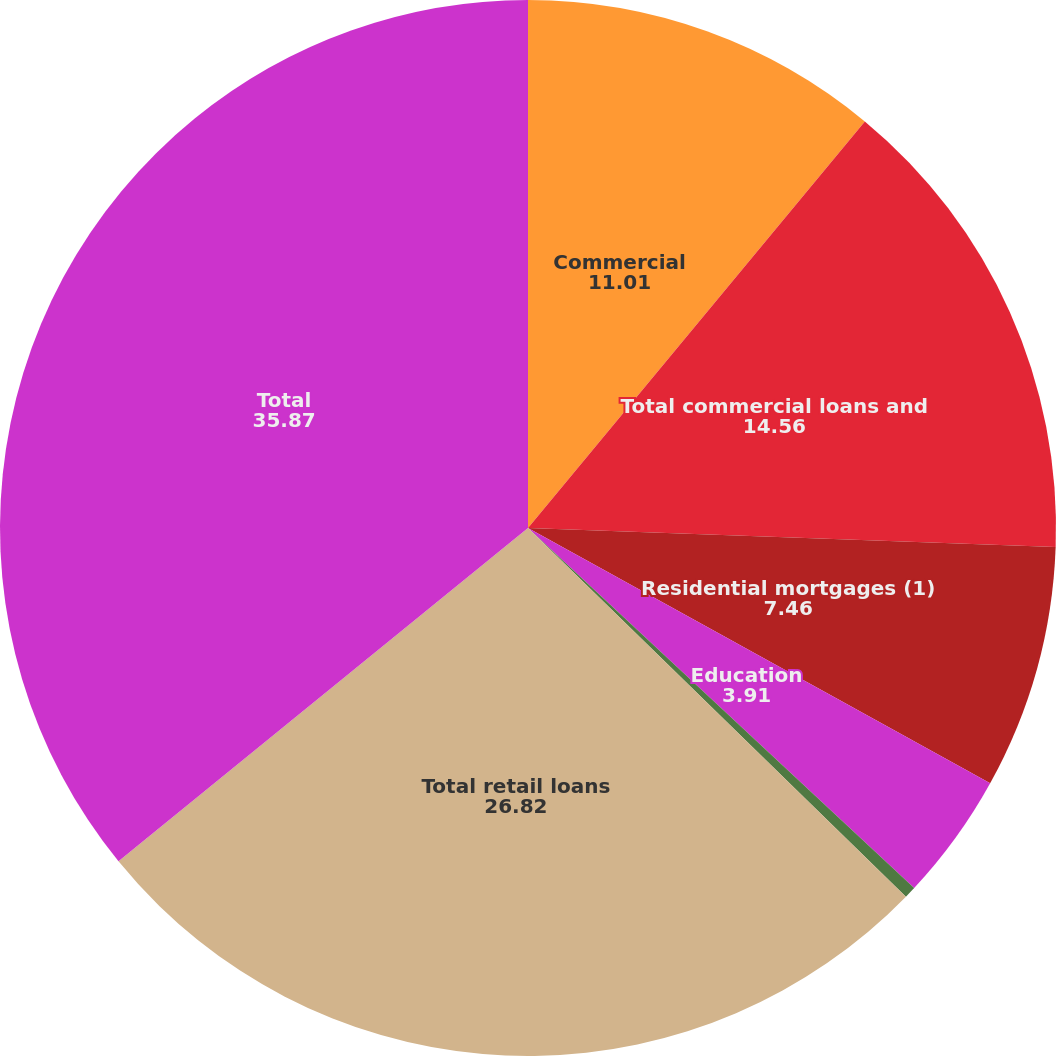<chart> <loc_0><loc_0><loc_500><loc_500><pie_chart><fcel>Commercial<fcel>Total commercial loans and<fcel>Residential mortgages (1)<fcel>Education<fcel>Other retail<fcel>Total retail loans<fcel>Total<nl><fcel>11.01%<fcel>14.56%<fcel>7.46%<fcel>3.91%<fcel>0.36%<fcel>26.82%<fcel>35.87%<nl></chart> 